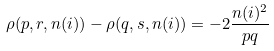Convert formula to latex. <formula><loc_0><loc_0><loc_500><loc_500>\rho ( p , r , n ( i ) ) - \rho ( q , s , n ( i ) ) = - 2 \frac { n ( i ) ^ { 2 } } { p q }</formula> 